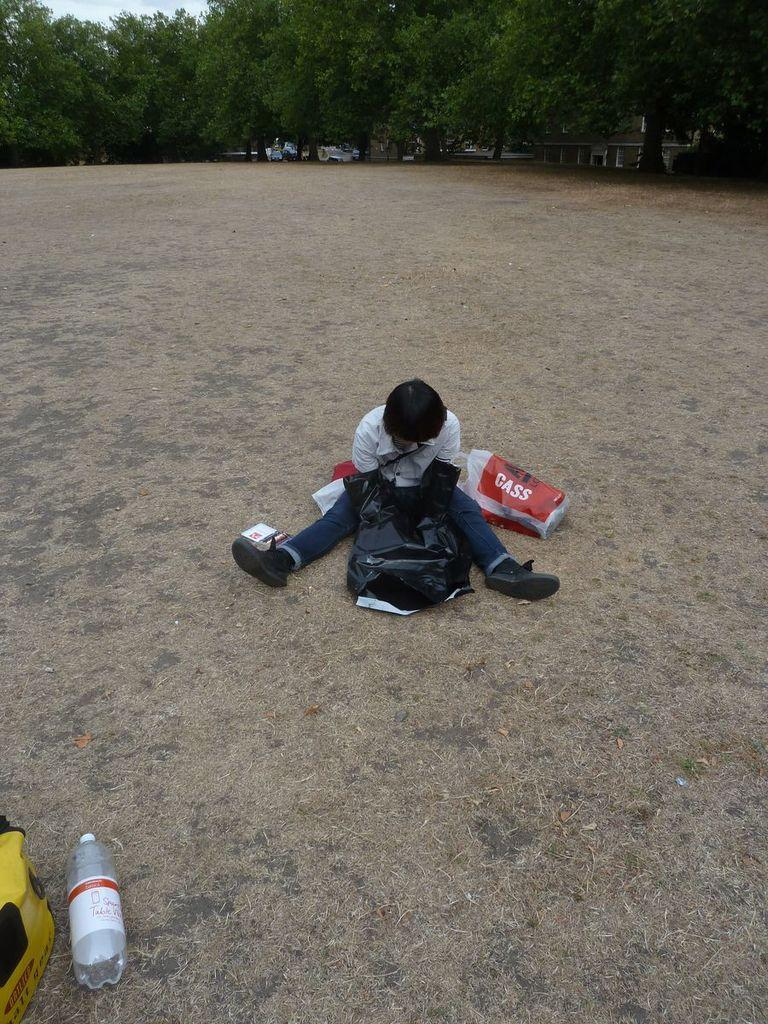What is the person in the image doing? There is a person sitting on the ground in the image. What objects can be seen near the person? There are bags and a bottle visible in the image. What can be seen in the background of the image? There are trees, vehicles, and the sky visible in the background of the image. Where is the faucet located in the image? There is no faucet present in the image. What shape is formed by the trees in the background of the image? The trees in the background do not form a specific shape; they are individual trees. 